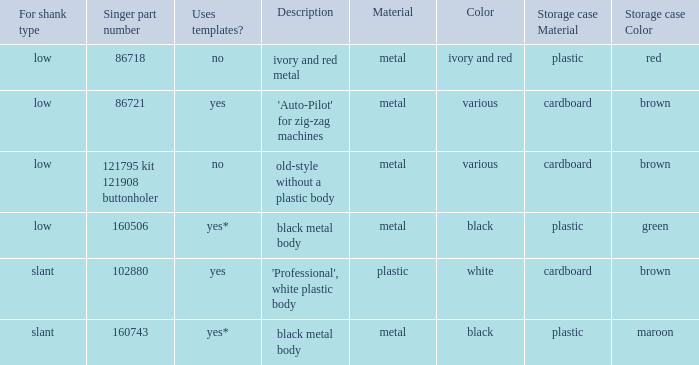What are the details for the buttonholer that has a singer part number of 121795 and comes in kit 121908? Old-style without a plastic body. 